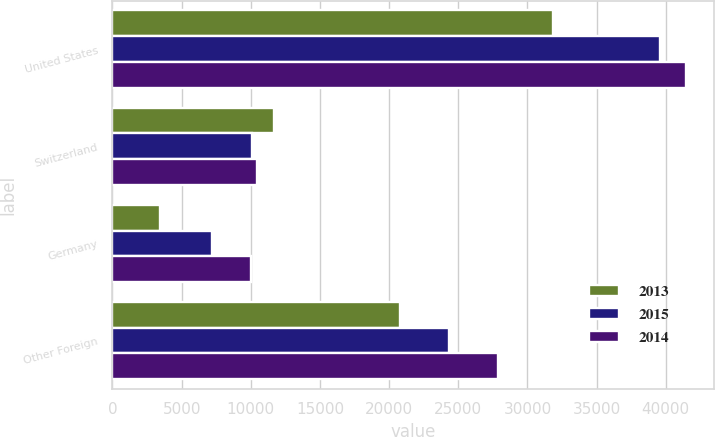Convert chart to OTSL. <chart><loc_0><loc_0><loc_500><loc_500><stacked_bar_chart><ecel><fcel>United States<fcel>Switzerland<fcel>Germany<fcel>Other Foreign<nl><fcel>2013<fcel>31828<fcel>11681<fcel>3436<fcel>20757<nl><fcel>2015<fcel>39609<fcel>10118<fcel>7174<fcel>24300<nl><fcel>2014<fcel>41427<fcel>10467<fcel>10029<fcel>27881<nl></chart> 